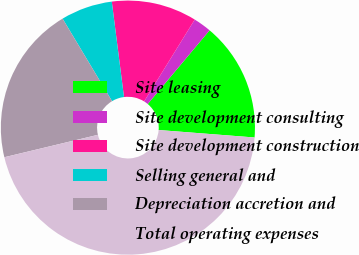<chart> <loc_0><loc_0><loc_500><loc_500><pie_chart><fcel>Site leasing<fcel>Site development consulting<fcel>Site development construction<fcel>Selling general and<fcel>Depreciation accretion and<fcel>Total operating expenses<nl><fcel>15.12%<fcel>2.3%<fcel>10.84%<fcel>6.57%<fcel>20.15%<fcel>45.02%<nl></chart> 